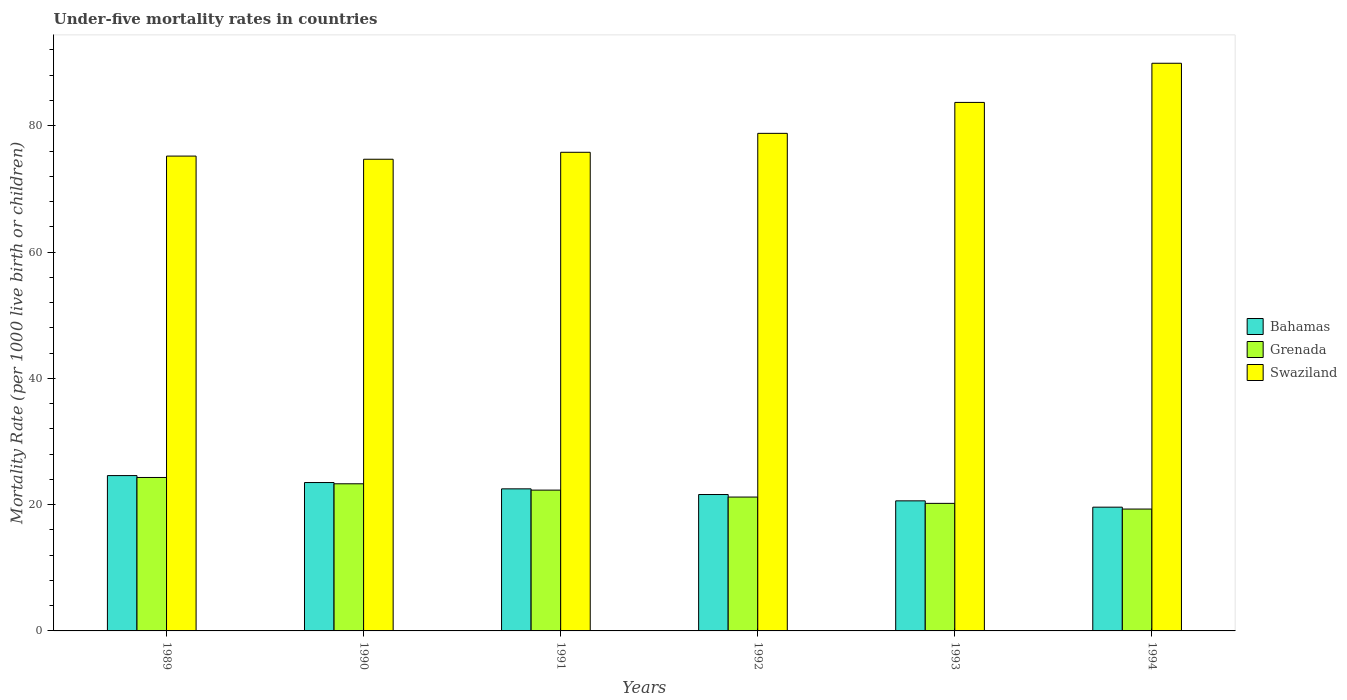How many different coloured bars are there?
Keep it short and to the point. 3. Are the number of bars per tick equal to the number of legend labels?
Give a very brief answer. Yes. Are the number of bars on each tick of the X-axis equal?
Offer a terse response. Yes. How many bars are there on the 4th tick from the left?
Offer a terse response. 3. What is the label of the 6th group of bars from the left?
Your answer should be very brief. 1994. In how many cases, is the number of bars for a given year not equal to the number of legend labels?
Your response must be concise. 0. What is the under-five mortality rate in Swaziland in 1993?
Make the answer very short. 83.7. Across all years, what is the maximum under-five mortality rate in Grenada?
Offer a terse response. 24.3. Across all years, what is the minimum under-five mortality rate in Swaziland?
Provide a succinct answer. 74.7. In which year was the under-five mortality rate in Bahamas maximum?
Give a very brief answer. 1989. What is the total under-five mortality rate in Grenada in the graph?
Give a very brief answer. 130.6. What is the difference between the under-five mortality rate in Swaziland in 1990 and that in 1993?
Your answer should be very brief. -9. What is the difference between the under-five mortality rate in Swaziland in 1989 and the under-five mortality rate in Bahamas in 1991?
Provide a short and direct response. 52.7. What is the average under-five mortality rate in Swaziland per year?
Provide a short and direct response. 79.68. In the year 1993, what is the difference between the under-five mortality rate in Grenada and under-five mortality rate in Bahamas?
Keep it short and to the point. -0.4. In how many years, is the under-five mortality rate in Bahamas greater than 20?
Provide a short and direct response. 5. What is the ratio of the under-five mortality rate in Swaziland in 1990 to that in 1994?
Ensure brevity in your answer.  0.83. Is the under-five mortality rate in Grenada in 1990 less than that in 1991?
Give a very brief answer. No. Is the difference between the under-five mortality rate in Grenada in 1992 and 1994 greater than the difference between the under-five mortality rate in Bahamas in 1992 and 1994?
Give a very brief answer. No. What is the difference between the highest and the second highest under-five mortality rate in Swaziland?
Offer a terse response. 6.2. In how many years, is the under-five mortality rate in Bahamas greater than the average under-five mortality rate in Bahamas taken over all years?
Provide a short and direct response. 3. Is the sum of the under-five mortality rate in Bahamas in 1993 and 1994 greater than the maximum under-five mortality rate in Swaziland across all years?
Your response must be concise. No. What does the 1st bar from the left in 1989 represents?
Your answer should be very brief. Bahamas. What does the 3rd bar from the right in 1991 represents?
Make the answer very short. Bahamas. Is it the case that in every year, the sum of the under-five mortality rate in Bahamas and under-five mortality rate in Swaziland is greater than the under-five mortality rate in Grenada?
Offer a very short reply. Yes. How many years are there in the graph?
Your answer should be very brief. 6. What is the difference between two consecutive major ticks on the Y-axis?
Your answer should be very brief. 20. Does the graph contain grids?
Make the answer very short. No. Where does the legend appear in the graph?
Offer a very short reply. Center right. How many legend labels are there?
Offer a terse response. 3. What is the title of the graph?
Offer a terse response. Under-five mortality rates in countries. Does "Fiji" appear as one of the legend labels in the graph?
Your answer should be very brief. No. What is the label or title of the Y-axis?
Keep it short and to the point. Mortality Rate (per 1000 live birth or children). What is the Mortality Rate (per 1000 live birth or children) of Bahamas in 1989?
Offer a very short reply. 24.6. What is the Mortality Rate (per 1000 live birth or children) of Grenada in 1989?
Provide a succinct answer. 24.3. What is the Mortality Rate (per 1000 live birth or children) in Swaziland in 1989?
Provide a short and direct response. 75.2. What is the Mortality Rate (per 1000 live birth or children) in Grenada in 1990?
Ensure brevity in your answer.  23.3. What is the Mortality Rate (per 1000 live birth or children) of Swaziland in 1990?
Make the answer very short. 74.7. What is the Mortality Rate (per 1000 live birth or children) of Grenada in 1991?
Your answer should be compact. 22.3. What is the Mortality Rate (per 1000 live birth or children) of Swaziland in 1991?
Your answer should be very brief. 75.8. What is the Mortality Rate (per 1000 live birth or children) in Bahamas in 1992?
Make the answer very short. 21.6. What is the Mortality Rate (per 1000 live birth or children) in Grenada in 1992?
Provide a short and direct response. 21.2. What is the Mortality Rate (per 1000 live birth or children) in Swaziland in 1992?
Provide a succinct answer. 78.8. What is the Mortality Rate (per 1000 live birth or children) in Bahamas in 1993?
Keep it short and to the point. 20.6. What is the Mortality Rate (per 1000 live birth or children) of Grenada in 1993?
Your response must be concise. 20.2. What is the Mortality Rate (per 1000 live birth or children) in Swaziland in 1993?
Your answer should be very brief. 83.7. What is the Mortality Rate (per 1000 live birth or children) in Bahamas in 1994?
Your response must be concise. 19.6. What is the Mortality Rate (per 1000 live birth or children) in Grenada in 1994?
Offer a very short reply. 19.3. What is the Mortality Rate (per 1000 live birth or children) of Swaziland in 1994?
Provide a succinct answer. 89.9. Across all years, what is the maximum Mortality Rate (per 1000 live birth or children) in Bahamas?
Provide a succinct answer. 24.6. Across all years, what is the maximum Mortality Rate (per 1000 live birth or children) in Grenada?
Provide a short and direct response. 24.3. Across all years, what is the maximum Mortality Rate (per 1000 live birth or children) of Swaziland?
Offer a very short reply. 89.9. Across all years, what is the minimum Mortality Rate (per 1000 live birth or children) of Bahamas?
Keep it short and to the point. 19.6. Across all years, what is the minimum Mortality Rate (per 1000 live birth or children) of Grenada?
Offer a terse response. 19.3. Across all years, what is the minimum Mortality Rate (per 1000 live birth or children) of Swaziland?
Keep it short and to the point. 74.7. What is the total Mortality Rate (per 1000 live birth or children) in Bahamas in the graph?
Provide a short and direct response. 132.4. What is the total Mortality Rate (per 1000 live birth or children) of Grenada in the graph?
Your response must be concise. 130.6. What is the total Mortality Rate (per 1000 live birth or children) in Swaziland in the graph?
Make the answer very short. 478.1. What is the difference between the Mortality Rate (per 1000 live birth or children) of Bahamas in 1989 and that in 1990?
Make the answer very short. 1.1. What is the difference between the Mortality Rate (per 1000 live birth or children) in Grenada in 1989 and that in 1991?
Offer a very short reply. 2. What is the difference between the Mortality Rate (per 1000 live birth or children) of Swaziland in 1989 and that in 1991?
Keep it short and to the point. -0.6. What is the difference between the Mortality Rate (per 1000 live birth or children) of Grenada in 1989 and that in 1992?
Make the answer very short. 3.1. What is the difference between the Mortality Rate (per 1000 live birth or children) of Swaziland in 1989 and that in 1992?
Make the answer very short. -3.6. What is the difference between the Mortality Rate (per 1000 live birth or children) in Swaziland in 1989 and that in 1994?
Your response must be concise. -14.7. What is the difference between the Mortality Rate (per 1000 live birth or children) of Grenada in 1990 and that in 1991?
Offer a very short reply. 1. What is the difference between the Mortality Rate (per 1000 live birth or children) in Bahamas in 1990 and that in 1993?
Offer a terse response. 2.9. What is the difference between the Mortality Rate (per 1000 live birth or children) in Grenada in 1990 and that in 1993?
Make the answer very short. 3.1. What is the difference between the Mortality Rate (per 1000 live birth or children) in Swaziland in 1990 and that in 1993?
Provide a short and direct response. -9. What is the difference between the Mortality Rate (per 1000 live birth or children) in Bahamas in 1990 and that in 1994?
Offer a terse response. 3.9. What is the difference between the Mortality Rate (per 1000 live birth or children) in Grenada in 1990 and that in 1994?
Offer a very short reply. 4. What is the difference between the Mortality Rate (per 1000 live birth or children) of Swaziland in 1990 and that in 1994?
Provide a succinct answer. -15.2. What is the difference between the Mortality Rate (per 1000 live birth or children) in Swaziland in 1991 and that in 1992?
Provide a succinct answer. -3. What is the difference between the Mortality Rate (per 1000 live birth or children) of Grenada in 1991 and that in 1993?
Your response must be concise. 2.1. What is the difference between the Mortality Rate (per 1000 live birth or children) of Swaziland in 1991 and that in 1993?
Provide a short and direct response. -7.9. What is the difference between the Mortality Rate (per 1000 live birth or children) in Grenada in 1991 and that in 1994?
Offer a very short reply. 3. What is the difference between the Mortality Rate (per 1000 live birth or children) of Swaziland in 1991 and that in 1994?
Your answer should be very brief. -14.1. What is the difference between the Mortality Rate (per 1000 live birth or children) of Grenada in 1992 and that in 1993?
Your answer should be compact. 1. What is the difference between the Mortality Rate (per 1000 live birth or children) in Swaziland in 1992 and that in 1993?
Make the answer very short. -4.9. What is the difference between the Mortality Rate (per 1000 live birth or children) in Swaziland in 1992 and that in 1994?
Provide a succinct answer. -11.1. What is the difference between the Mortality Rate (per 1000 live birth or children) of Bahamas in 1993 and that in 1994?
Make the answer very short. 1. What is the difference between the Mortality Rate (per 1000 live birth or children) in Grenada in 1993 and that in 1994?
Offer a very short reply. 0.9. What is the difference between the Mortality Rate (per 1000 live birth or children) in Swaziland in 1993 and that in 1994?
Make the answer very short. -6.2. What is the difference between the Mortality Rate (per 1000 live birth or children) in Bahamas in 1989 and the Mortality Rate (per 1000 live birth or children) in Grenada in 1990?
Give a very brief answer. 1.3. What is the difference between the Mortality Rate (per 1000 live birth or children) in Bahamas in 1989 and the Mortality Rate (per 1000 live birth or children) in Swaziland in 1990?
Provide a succinct answer. -50.1. What is the difference between the Mortality Rate (per 1000 live birth or children) of Grenada in 1989 and the Mortality Rate (per 1000 live birth or children) of Swaziland in 1990?
Your answer should be compact. -50.4. What is the difference between the Mortality Rate (per 1000 live birth or children) of Bahamas in 1989 and the Mortality Rate (per 1000 live birth or children) of Swaziland in 1991?
Give a very brief answer. -51.2. What is the difference between the Mortality Rate (per 1000 live birth or children) in Grenada in 1989 and the Mortality Rate (per 1000 live birth or children) in Swaziland in 1991?
Offer a terse response. -51.5. What is the difference between the Mortality Rate (per 1000 live birth or children) in Bahamas in 1989 and the Mortality Rate (per 1000 live birth or children) in Swaziland in 1992?
Your answer should be very brief. -54.2. What is the difference between the Mortality Rate (per 1000 live birth or children) of Grenada in 1989 and the Mortality Rate (per 1000 live birth or children) of Swaziland in 1992?
Offer a very short reply. -54.5. What is the difference between the Mortality Rate (per 1000 live birth or children) of Bahamas in 1989 and the Mortality Rate (per 1000 live birth or children) of Swaziland in 1993?
Keep it short and to the point. -59.1. What is the difference between the Mortality Rate (per 1000 live birth or children) of Grenada in 1989 and the Mortality Rate (per 1000 live birth or children) of Swaziland in 1993?
Offer a terse response. -59.4. What is the difference between the Mortality Rate (per 1000 live birth or children) in Bahamas in 1989 and the Mortality Rate (per 1000 live birth or children) in Swaziland in 1994?
Provide a succinct answer. -65.3. What is the difference between the Mortality Rate (per 1000 live birth or children) in Grenada in 1989 and the Mortality Rate (per 1000 live birth or children) in Swaziland in 1994?
Provide a short and direct response. -65.6. What is the difference between the Mortality Rate (per 1000 live birth or children) in Bahamas in 1990 and the Mortality Rate (per 1000 live birth or children) in Swaziland in 1991?
Your response must be concise. -52.3. What is the difference between the Mortality Rate (per 1000 live birth or children) of Grenada in 1990 and the Mortality Rate (per 1000 live birth or children) of Swaziland in 1991?
Provide a succinct answer. -52.5. What is the difference between the Mortality Rate (per 1000 live birth or children) in Bahamas in 1990 and the Mortality Rate (per 1000 live birth or children) in Swaziland in 1992?
Your answer should be compact. -55.3. What is the difference between the Mortality Rate (per 1000 live birth or children) of Grenada in 1990 and the Mortality Rate (per 1000 live birth or children) of Swaziland in 1992?
Provide a succinct answer. -55.5. What is the difference between the Mortality Rate (per 1000 live birth or children) of Bahamas in 1990 and the Mortality Rate (per 1000 live birth or children) of Swaziland in 1993?
Ensure brevity in your answer.  -60.2. What is the difference between the Mortality Rate (per 1000 live birth or children) of Grenada in 1990 and the Mortality Rate (per 1000 live birth or children) of Swaziland in 1993?
Make the answer very short. -60.4. What is the difference between the Mortality Rate (per 1000 live birth or children) in Bahamas in 1990 and the Mortality Rate (per 1000 live birth or children) in Swaziland in 1994?
Offer a terse response. -66.4. What is the difference between the Mortality Rate (per 1000 live birth or children) of Grenada in 1990 and the Mortality Rate (per 1000 live birth or children) of Swaziland in 1994?
Keep it short and to the point. -66.6. What is the difference between the Mortality Rate (per 1000 live birth or children) in Bahamas in 1991 and the Mortality Rate (per 1000 live birth or children) in Grenada in 1992?
Ensure brevity in your answer.  1.3. What is the difference between the Mortality Rate (per 1000 live birth or children) in Bahamas in 1991 and the Mortality Rate (per 1000 live birth or children) in Swaziland in 1992?
Offer a very short reply. -56.3. What is the difference between the Mortality Rate (per 1000 live birth or children) in Grenada in 1991 and the Mortality Rate (per 1000 live birth or children) in Swaziland in 1992?
Your answer should be very brief. -56.5. What is the difference between the Mortality Rate (per 1000 live birth or children) of Bahamas in 1991 and the Mortality Rate (per 1000 live birth or children) of Grenada in 1993?
Give a very brief answer. 2.3. What is the difference between the Mortality Rate (per 1000 live birth or children) in Bahamas in 1991 and the Mortality Rate (per 1000 live birth or children) in Swaziland in 1993?
Provide a short and direct response. -61.2. What is the difference between the Mortality Rate (per 1000 live birth or children) in Grenada in 1991 and the Mortality Rate (per 1000 live birth or children) in Swaziland in 1993?
Keep it short and to the point. -61.4. What is the difference between the Mortality Rate (per 1000 live birth or children) in Bahamas in 1991 and the Mortality Rate (per 1000 live birth or children) in Swaziland in 1994?
Your answer should be compact. -67.4. What is the difference between the Mortality Rate (per 1000 live birth or children) in Grenada in 1991 and the Mortality Rate (per 1000 live birth or children) in Swaziland in 1994?
Offer a terse response. -67.6. What is the difference between the Mortality Rate (per 1000 live birth or children) in Bahamas in 1992 and the Mortality Rate (per 1000 live birth or children) in Grenada in 1993?
Your answer should be compact. 1.4. What is the difference between the Mortality Rate (per 1000 live birth or children) of Bahamas in 1992 and the Mortality Rate (per 1000 live birth or children) of Swaziland in 1993?
Your answer should be very brief. -62.1. What is the difference between the Mortality Rate (per 1000 live birth or children) of Grenada in 1992 and the Mortality Rate (per 1000 live birth or children) of Swaziland in 1993?
Provide a short and direct response. -62.5. What is the difference between the Mortality Rate (per 1000 live birth or children) of Bahamas in 1992 and the Mortality Rate (per 1000 live birth or children) of Grenada in 1994?
Provide a succinct answer. 2.3. What is the difference between the Mortality Rate (per 1000 live birth or children) in Bahamas in 1992 and the Mortality Rate (per 1000 live birth or children) in Swaziland in 1994?
Give a very brief answer. -68.3. What is the difference between the Mortality Rate (per 1000 live birth or children) of Grenada in 1992 and the Mortality Rate (per 1000 live birth or children) of Swaziland in 1994?
Give a very brief answer. -68.7. What is the difference between the Mortality Rate (per 1000 live birth or children) of Bahamas in 1993 and the Mortality Rate (per 1000 live birth or children) of Grenada in 1994?
Your answer should be very brief. 1.3. What is the difference between the Mortality Rate (per 1000 live birth or children) in Bahamas in 1993 and the Mortality Rate (per 1000 live birth or children) in Swaziland in 1994?
Give a very brief answer. -69.3. What is the difference between the Mortality Rate (per 1000 live birth or children) in Grenada in 1993 and the Mortality Rate (per 1000 live birth or children) in Swaziland in 1994?
Provide a short and direct response. -69.7. What is the average Mortality Rate (per 1000 live birth or children) in Bahamas per year?
Make the answer very short. 22.07. What is the average Mortality Rate (per 1000 live birth or children) in Grenada per year?
Keep it short and to the point. 21.77. What is the average Mortality Rate (per 1000 live birth or children) of Swaziland per year?
Your answer should be compact. 79.68. In the year 1989, what is the difference between the Mortality Rate (per 1000 live birth or children) of Bahamas and Mortality Rate (per 1000 live birth or children) of Grenada?
Your response must be concise. 0.3. In the year 1989, what is the difference between the Mortality Rate (per 1000 live birth or children) of Bahamas and Mortality Rate (per 1000 live birth or children) of Swaziland?
Your answer should be compact. -50.6. In the year 1989, what is the difference between the Mortality Rate (per 1000 live birth or children) of Grenada and Mortality Rate (per 1000 live birth or children) of Swaziland?
Give a very brief answer. -50.9. In the year 1990, what is the difference between the Mortality Rate (per 1000 live birth or children) of Bahamas and Mortality Rate (per 1000 live birth or children) of Swaziland?
Your answer should be compact. -51.2. In the year 1990, what is the difference between the Mortality Rate (per 1000 live birth or children) in Grenada and Mortality Rate (per 1000 live birth or children) in Swaziland?
Provide a short and direct response. -51.4. In the year 1991, what is the difference between the Mortality Rate (per 1000 live birth or children) in Bahamas and Mortality Rate (per 1000 live birth or children) in Swaziland?
Give a very brief answer. -53.3. In the year 1991, what is the difference between the Mortality Rate (per 1000 live birth or children) of Grenada and Mortality Rate (per 1000 live birth or children) of Swaziland?
Make the answer very short. -53.5. In the year 1992, what is the difference between the Mortality Rate (per 1000 live birth or children) in Bahamas and Mortality Rate (per 1000 live birth or children) in Swaziland?
Your answer should be very brief. -57.2. In the year 1992, what is the difference between the Mortality Rate (per 1000 live birth or children) in Grenada and Mortality Rate (per 1000 live birth or children) in Swaziland?
Ensure brevity in your answer.  -57.6. In the year 1993, what is the difference between the Mortality Rate (per 1000 live birth or children) in Bahamas and Mortality Rate (per 1000 live birth or children) in Swaziland?
Provide a succinct answer. -63.1. In the year 1993, what is the difference between the Mortality Rate (per 1000 live birth or children) in Grenada and Mortality Rate (per 1000 live birth or children) in Swaziland?
Your answer should be compact. -63.5. In the year 1994, what is the difference between the Mortality Rate (per 1000 live birth or children) in Bahamas and Mortality Rate (per 1000 live birth or children) in Grenada?
Offer a very short reply. 0.3. In the year 1994, what is the difference between the Mortality Rate (per 1000 live birth or children) of Bahamas and Mortality Rate (per 1000 live birth or children) of Swaziland?
Offer a very short reply. -70.3. In the year 1994, what is the difference between the Mortality Rate (per 1000 live birth or children) of Grenada and Mortality Rate (per 1000 live birth or children) of Swaziland?
Make the answer very short. -70.6. What is the ratio of the Mortality Rate (per 1000 live birth or children) in Bahamas in 1989 to that in 1990?
Provide a succinct answer. 1.05. What is the ratio of the Mortality Rate (per 1000 live birth or children) in Grenada in 1989 to that in 1990?
Keep it short and to the point. 1.04. What is the ratio of the Mortality Rate (per 1000 live birth or children) of Bahamas in 1989 to that in 1991?
Provide a short and direct response. 1.09. What is the ratio of the Mortality Rate (per 1000 live birth or children) in Grenada in 1989 to that in 1991?
Offer a very short reply. 1.09. What is the ratio of the Mortality Rate (per 1000 live birth or children) in Swaziland in 1989 to that in 1991?
Offer a terse response. 0.99. What is the ratio of the Mortality Rate (per 1000 live birth or children) of Bahamas in 1989 to that in 1992?
Offer a very short reply. 1.14. What is the ratio of the Mortality Rate (per 1000 live birth or children) in Grenada in 1989 to that in 1992?
Give a very brief answer. 1.15. What is the ratio of the Mortality Rate (per 1000 live birth or children) of Swaziland in 1989 to that in 1992?
Provide a short and direct response. 0.95. What is the ratio of the Mortality Rate (per 1000 live birth or children) in Bahamas in 1989 to that in 1993?
Provide a short and direct response. 1.19. What is the ratio of the Mortality Rate (per 1000 live birth or children) of Grenada in 1989 to that in 1993?
Your answer should be compact. 1.2. What is the ratio of the Mortality Rate (per 1000 live birth or children) in Swaziland in 1989 to that in 1993?
Ensure brevity in your answer.  0.9. What is the ratio of the Mortality Rate (per 1000 live birth or children) of Bahamas in 1989 to that in 1994?
Your response must be concise. 1.26. What is the ratio of the Mortality Rate (per 1000 live birth or children) in Grenada in 1989 to that in 1994?
Your response must be concise. 1.26. What is the ratio of the Mortality Rate (per 1000 live birth or children) in Swaziland in 1989 to that in 1994?
Offer a terse response. 0.84. What is the ratio of the Mortality Rate (per 1000 live birth or children) of Bahamas in 1990 to that in 1991?
Ensure brevity in your answer.  1.04. What is the ratio of the Mortality Rate (per 1000 live birth or children) in Grenada in 1990 to that in 1991?
Offer a very short reply. 1.04. What is the ratio of the Mortality Rate (per 1000 live birth or children) of Swaziland in 1990 to that in 1991?
Ensure brevity in your answer.  0.99. What is the ratio of the Mortality Rate (per 1000 live birth or children) in Bahamas in 1990 to that in 1992?
Keep it short and to the point. 1.09. What is the ratio of the Mortality Rate (per 1000 live birth or children) of Grenada in 1990 to that in 1992?
Your response must be concise. 1.1. What is the ratio of the Mortality Rate (per 1000 live birth or children) in Swaziland in 1990 to that in 1992?
Provide a succinct answer. 0.95. What is the ratio of the Mortality Rate (per 1000 live birth or children) in Bahamas in 1990 to that in 1993?
Provide a short and direct response. 1.14. What is the ratio of the Mortality Rate (per 1000 live birth or children) of Grenada in 1990 to that in 1993?
Provide a short and direct response. 1.15. What is the ratio of the Mortality Rate (per 1000 live birth or children) of Swaziland in 1990 to that in 1993?
Your response must be concise. 0.89. What is the ratio of the Mortality Rate (per 1000 live birth or children) of Bahamas in 1990 to that in 1994?
Offer a very short reply. 1.2. What is the ratio of the Mortality Rate (per 1000 live birth or children) of Grenada in 1990 to that in 1994?
Provide a short and direct response. 1.21. What is the ratio of the Mortality Rate (per 1000 live birth or children) of Swaziland in 1990 to that in 1994?
Give a very brief answer. 0.83. What is the ratio of the Mortality Rate (per 1000 live birth or children) in Bahamas in 1991 to that in 1992?
Your response must be concise. 1.04. What is the ratio of the Mortality Rate (per 1000 live birth or children) of Grenada in 1991 to that in 1992?
Offer a very short reply. 1.05. What is the ratio of the Mortality Rate (per 1000 live birth or children) in Swaziland in 1991 to that in 1992?
Provide a short and direct response. 0.96. What is the ratio of the Mortality Rate (per 1000 live birth or children) in Bahamas in 1991 to that in 1993?
Offer a terse response. 1.09. What is the ratio of the Mortality Rate (per 1000 live birth or children) in Grenada in 1991 to that in 1993?
Give a very brief answer. 1.1. What is the ratio of the Mortality Rate (per 1000 live birth or children) of Swaziland in 1991 to that in 1993?
Offer a terse response. 0.91. What is the ratio of the Mortality Rate (per 1000 live birth or children) in Bahamas in 1991 to that in 1994?
Offer a terse response. 1.15. What is the ratio of the Mortality Rate (per 1000 live birth or children) in Grenada in 1991 to that in 1994?
Keep it short and to the point. 1.16. What is the ratio of the Mortality Rate (per 1000 live birth or children) of Swaziland in 1991 to that in 1994?
Your answer should be compact. 0.84. What is the ratio of the Mortality Rate (per 1000 live birth or children) of Bahamas in 1992 to that in 1993?
Provide a short and direct response. 1.05. What is the ratio of the Mortality Rate (per 1000 live birth or children) of Grenada in 1992 to that in 1993?
Offer a terse response. 1.05. What is the ratio of the Mortality Rate (per 1000 live birth or children) in Swaziland in 1992 to that in 1993?
Provide a succinct answer. 0.94. What is the ratio of the Mortality Rate (per 1000 live birth or children) in Bahamas in 1992 to that in 1994?
Your answer should be compact. 1.1. What is the ratio of the Mortality Rate (per 1000 live birth or children) of Grenada in 1992 to that in 1994?
Your response must be concise. 1.1. What is the ratio of the Mortality Rate (per 1000 live birth or children) of Swaziland in 1992 to that in 1994?
Your answer should be very brief. 0.88. What is the ratio of the Mortality Rate (per 1000 live birth or children) in Bahamas in 1993 to that in 1994?
Make the answer very short. 1.05. What is the ratio of the Mortality Rate (per 1000 live birth or children) in Grenada in 1993 to that in 1994?
Offer a terse response. 1.05. What is the difference between the highest and the second highest Mortality Rate (per 1000 live birth or children) of Grenada?
Your answer should be compact. 1. What is the difference between the highest and the lowest Mortality Rate (per 1000 live birth or children) in Grenada?
Keep it short and to the point. 5. What is the difference between the highest and the lowest Mortality Rate (per 1000 live birth or children) in Swaziland?
Make the answer very short. 15.2. 